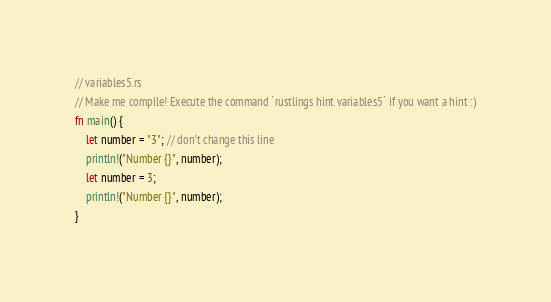<code> <loc_0><loc_0><loc_500><loc_500><_Rust_>// variables5.rs
// Make me compile! Execute the command `rustlings hint variables5` if you want a hint :)
fn main() {
    let number = "3"; // don't change this line
    println!("Number {}", number);
    let number = 3;
    println!("Number {}", number);
}
</code> 